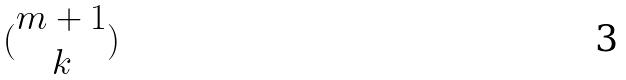<formula> <loc_0><loc_0><loc_500><loc_500>( \begin{matrix} m + 1 \\ k \end{matrix} )</formula> 